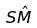Convert formula to latex. <formula><loc_0><loc_0><loc_500><loc_500>S \hat { M }</formula> 